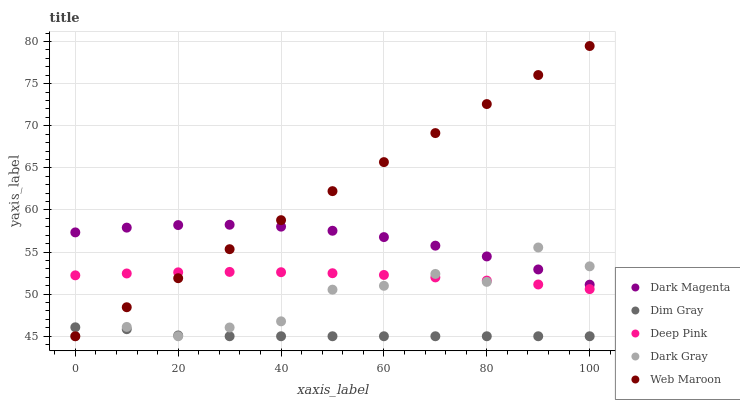Does Dim Gray have the minimum area under the curve?
Answer yes or no. Yes. Does Web Maroon have the maximum area under the curve?
Answer yes or no. Yes. Does Web Maroon have the minimum area under the curve?
Answer yes or no. No. Does Dim Gray have the maximum area under the curve?
Answer yes or no. No. Is Web Maroon the smoothest?
Answer yes or no. Yes. Is Dark Gray the roughest?
Answer yes or no. Yes. Is Dim Gray the smoothest?
Answer yes or no. No. Is Dim Gray the roughest?
Answer yes or no. No. Does Dark Gray have the lowest value?
Answer yes or no. Yes. Does Dark Magenta have the lowest value?
Answer yes or no. No. Does Web Maroon have the highest value?
Answer yes or no. Yes. Does Dim Gray have the highest value?
Answer yes or no. No. Is Dim Gray less than Dark Magenta?
Answer yes or no. Yes. Is Dark Magenta greater than Deep Pink?
Answer yes or no. Yes. Does Dim Gray intersect Web Maroon?
Answer yes or no. Yes. Is Dim Gray less than Web Maroon?
Answer yes or no. No. Is Dim Gray greater than Web Maroon?
Answer yes or no. No. Does Dim Gray intersect Dark Magenta?
Answer yes or no. No. 